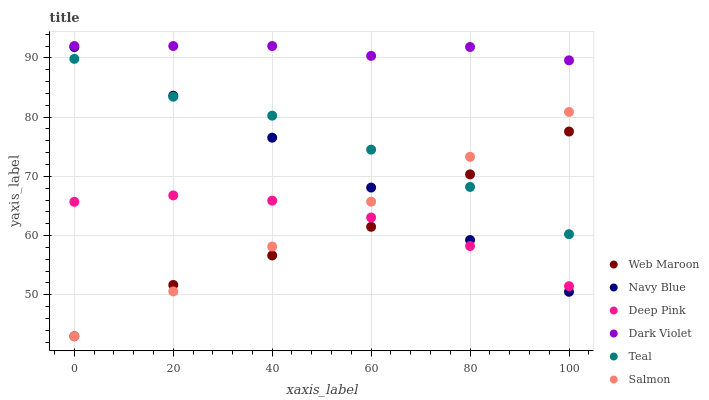Does Web Maroon have the minimum area under the curve?
Answer yes or no. Yes. Does Dark Violet have the maximum area under the curve?
Answer yes or no. Yes. Does Navy Blue have the minimum area under the curve?
Answer yes or no. No. Does Navy Blue have the maximum area under the curve?
Answer yes or no. No. Is Salmon the smoothest?
Answer yes or no. Yes. Is Web Maroon the roughest?
Answer yes or no. Yes. Is Navy Blue the smoothest?
Answer yes or no. No. Is Navy Blue the roughest?
Answer yes or no. No. Does Web Maroon have the lowest value?
Answer yes or no. Yes. Does Navy Blue have the lowest value?
Answer yes or no. No. Does Dark Violet have the highest value?
Answer yes or no. Yes. Does Navy Blue have the highest value?
Answer yes or no. No. Is Teal less than Dark Violet?
Answer yes or no. Yes. Is Teal greater than Deep Pink?
Answer yes or no. Yes. Does Navy Blue intersect Teal?
Answer yes or no. Yes. Is Navy Blue less than Teal?
Answer yes or no. No. Is Navy Blue greater than Teal?
Answer yes or no. No. Does Teal intersect Dark Violet?
Answer yes or no. No. 